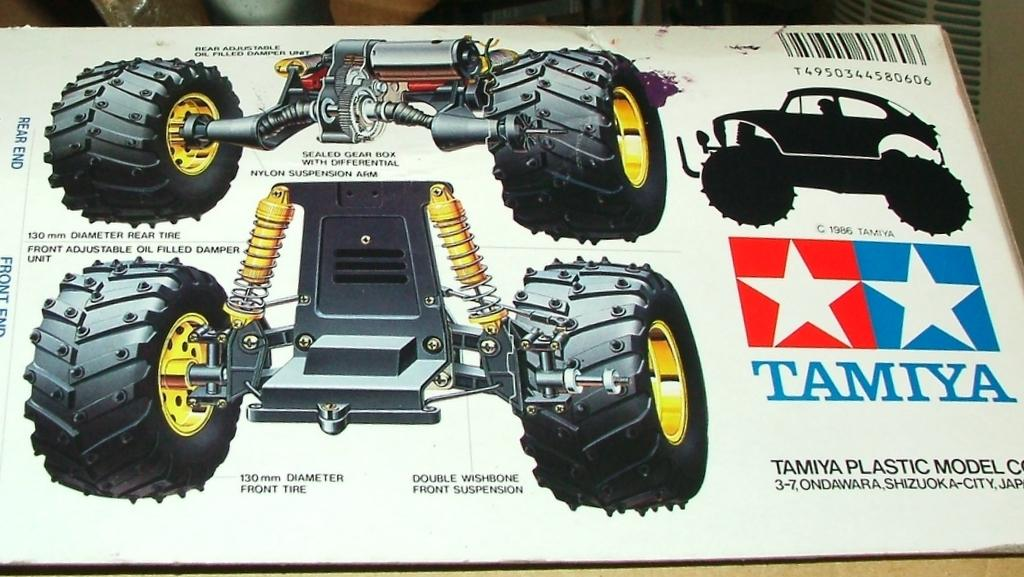What is the main object in the picture? There is a box in the picture. What else can be seen in the picture besides the box? There is a poster with vehicle parts and wheels in the picture. Can you describe the poster in more detail? The label "TANYA" is written on the poster, accompanied by two star symbols. What type of beginner's vest is visible in the picture? There is no vest present in the picture. 